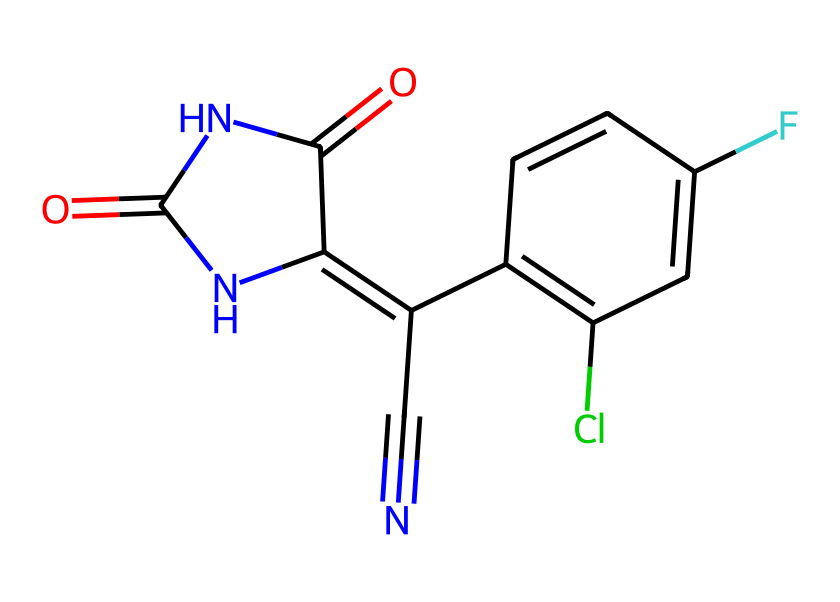What is the molecular formula of fludioxonil? To find the molecular formula, we need to count the number of each type of atom in the SMILES representation. Analyzing the structure reveals there are 12 carbons (C), 8 hydrogens (H), 2 nitrogens (N), 1 oxygen (O), 1 chlorine (Cl), and 1 fluorine (F). Thus, the molecular formula is C12H8ClF2N2O2.
Answer: C12H8ClF2N2O2 How many rings are present in the structure of fludioxonil? Looking at the SMILES, the structure contains two rings connected to the main chain. The presence of the “C” atoms that form a closed loop indicates these rings. Thus, we count 2 distinct ring systems.
Answer: 2 What functional groups are present in fludioxonil? In the SMILES representation, we can identify a carbonyl group (C=O) and an aromatic ring system due to the presence of alternating double bonds. Additionally, it contains a cyanide group (C#N). Combining these observations, we conclude there are ketone and cyanide functional groups.
Answer: ketone and cyanide Which element is represented as a substituent on the aromatic system? By analyzing the aromatic structure in the SMILES, the chlorine (Cl) and fluorine (F) atoms are identified as substituents. They are attached to one of the aromatic rings visible in the structure.
Answer: chlorine and fluorine What is the total number of nitrogen atoms in fludioxonil? The SMILES string includes two distinct nitrogen atoms, which are indicated by the presence of the “N” components. These count towards the total number of nitrogen atoms in the structure.
Answer: 2 How does the structure of fludioxonil contribute to its fungicidal properties? The presence of multiple functional groups, particularly the aromatic rings and the carbonyl groups, increases the molecule's lipophilicity, enabling it to penetrate fungal membranes effectively. This structural consideration explains its capacity to function as a potent fungicide.
Answer: enhances permeability What type of chemical is fludioxonil classified as? Because fludioxonil is specifically designed to inhibit fungal growth and is represented in various agricultural fungicides, it is primarily classified as a fungicide.
Answer: fungicide 